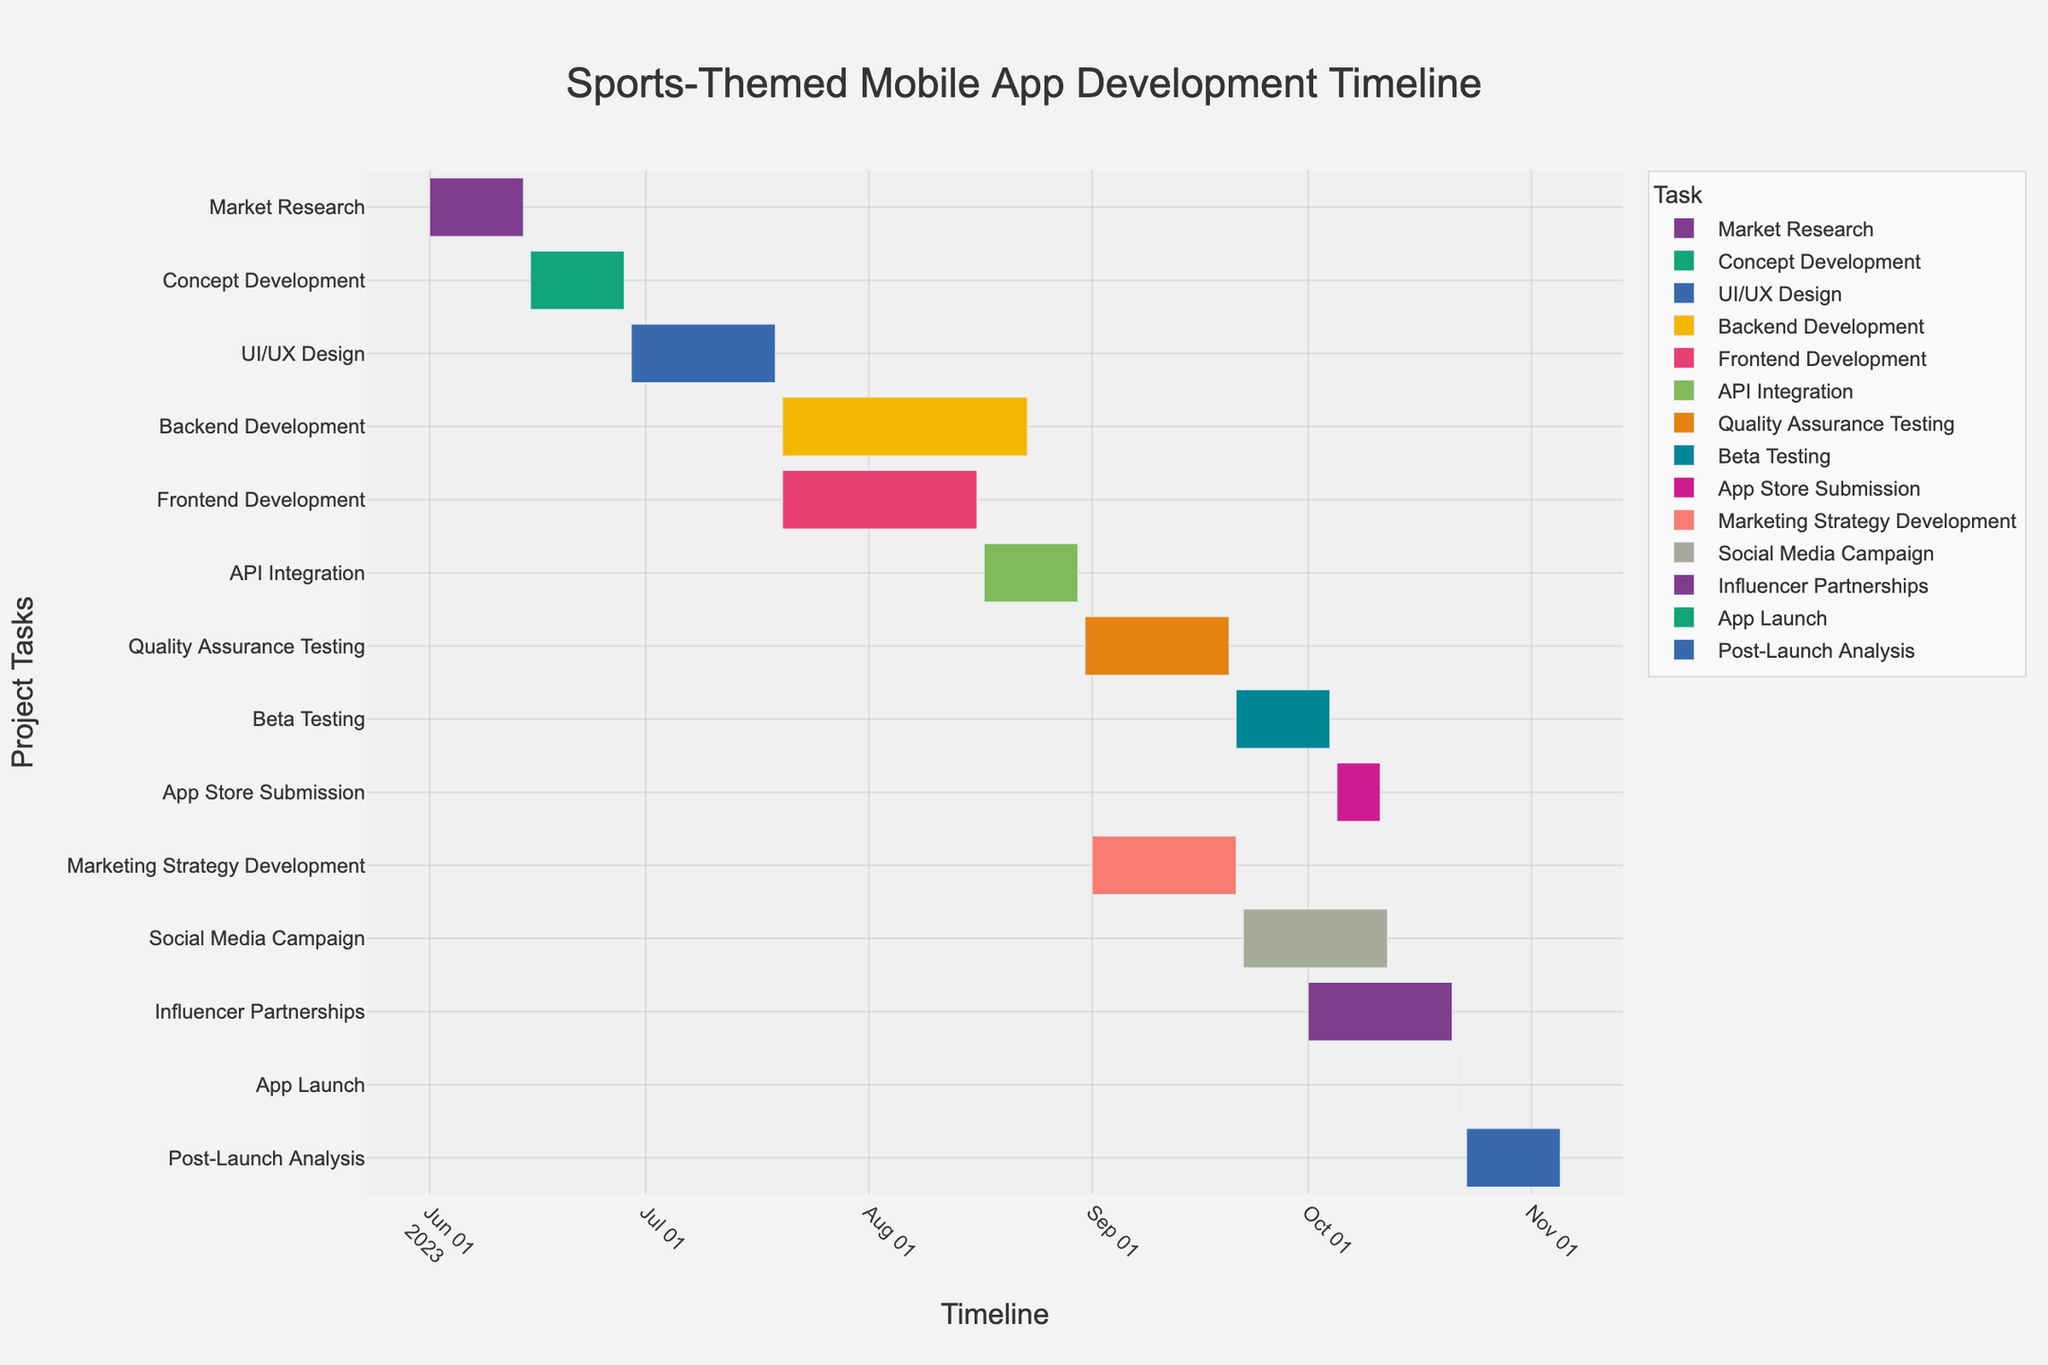What's the title of the figure? The title is usually positioned at the top of the chart. By reading it, you can directly identify the name of the figure.
Answer: Sports-Themed Mobile App Development Timeline How long is the Backend Development stage? To determine the length of the Backend Development stage, look at its Start Date (2023-07-20) and End Date (2023-08-23). Calculate the number of days between these dates. Alternatively, look at the Duration column, which shows the number of days as 35.
Answer: 35 days Which task has the shortest duration? Examine the Duration column and find the task with the smallest number of days. The App Launch has a duration of just 1 day.
Answer: App Launch What is the total duration of the Marketing Strategy Development and Social Media Campaign tasks combined? Add the duration of the Marketing Strategy Development (21 days) and Social Media Campaign (21 days). 21 + 21 = 42 days.
Answer: 42 days During which months does Beta Testing take place? Look at the Start Date (2023-09-21) and End Date (2023-10-04) of the Beta Testing task. This period covers part of September and October.
Answer: September and October Which tasks are overlapping with Backend Development? Identify the Backend Development task's timeframe (2023-07-20 to 2023-08-23) and find any tasks within this period. The Frontend Development task overlaps, starting on 2023-07-20 and ending on 2023-08-16.
Answer: Frontend Development When does the Post-Launch Analysis start and end? Locate the Post-Launch Analysis task on the Y-axis and refer to its Start Date and End Date. It starts on 2023-10-23 and ends on 2023-11-05.
Answer: 2023-10-23 to 2023-11-05 Which task immediately follows Quality Assurance Testing? Find the Quality Assurance Testing task and check what comes right after it on the timeline. The next task is Beta Testing, which starts on 2023-09-21.
Answer: Beta Testing What is the overall time span from the start of Market Research to the end of Post-Launch Analysis? Identify the dates for the start of Market Research (2023-06-01) and the end of Post-Launch Analysis (2023-11-05). Calculate the total number of days between these dates. There are 157 days between these two points.
Answer: 157 days How many tasks are planned to start within the month of September? Look at the Start Dates of all tasks and count those that fall within the month of September. Quality Assurance Testing (2023-08-31), Beta Testing (2023-09-21), Marketing Strategy Development (2023-09-01), and Social Media Campaign (2023-09-22), Beta Testing has end date fall into September while App Store Submission starts later on 2023-10-05. There are thus 3 tasks starting in September.
Answer: 3 tasks 